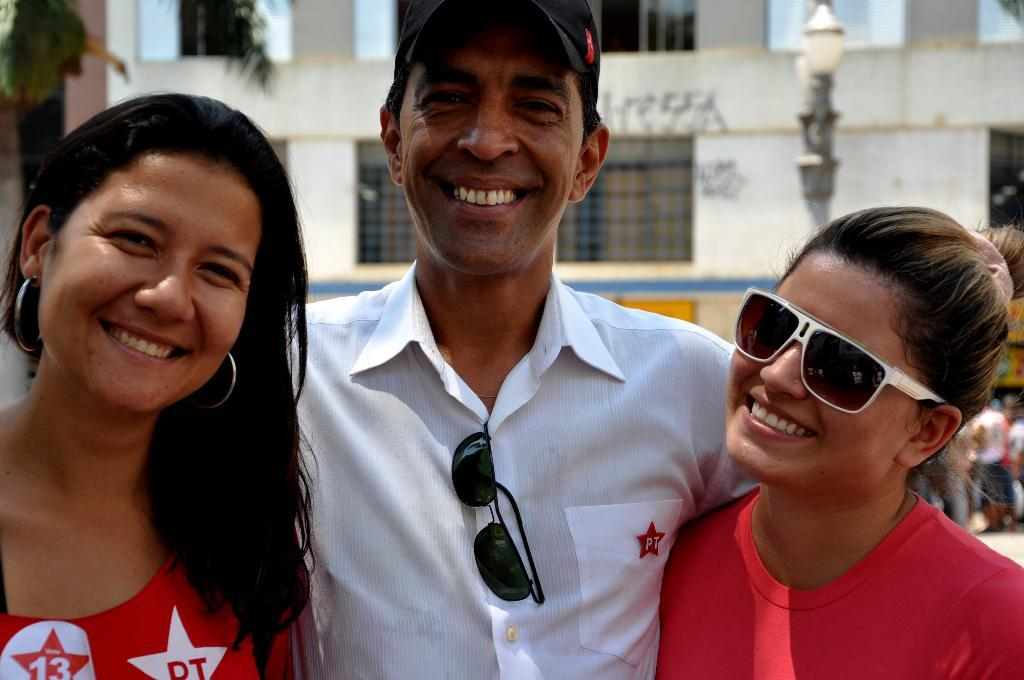How many people are present in the image? There are three people in the image: one man and two women. What are the people in the image doing? The man and the women are smiling. What can be seen in the background of the image? There is a building and light visible in the background of the image. What scent can be detected from the man in the image? There is no information about the scent of the man in the image, as it is a visual medium. 